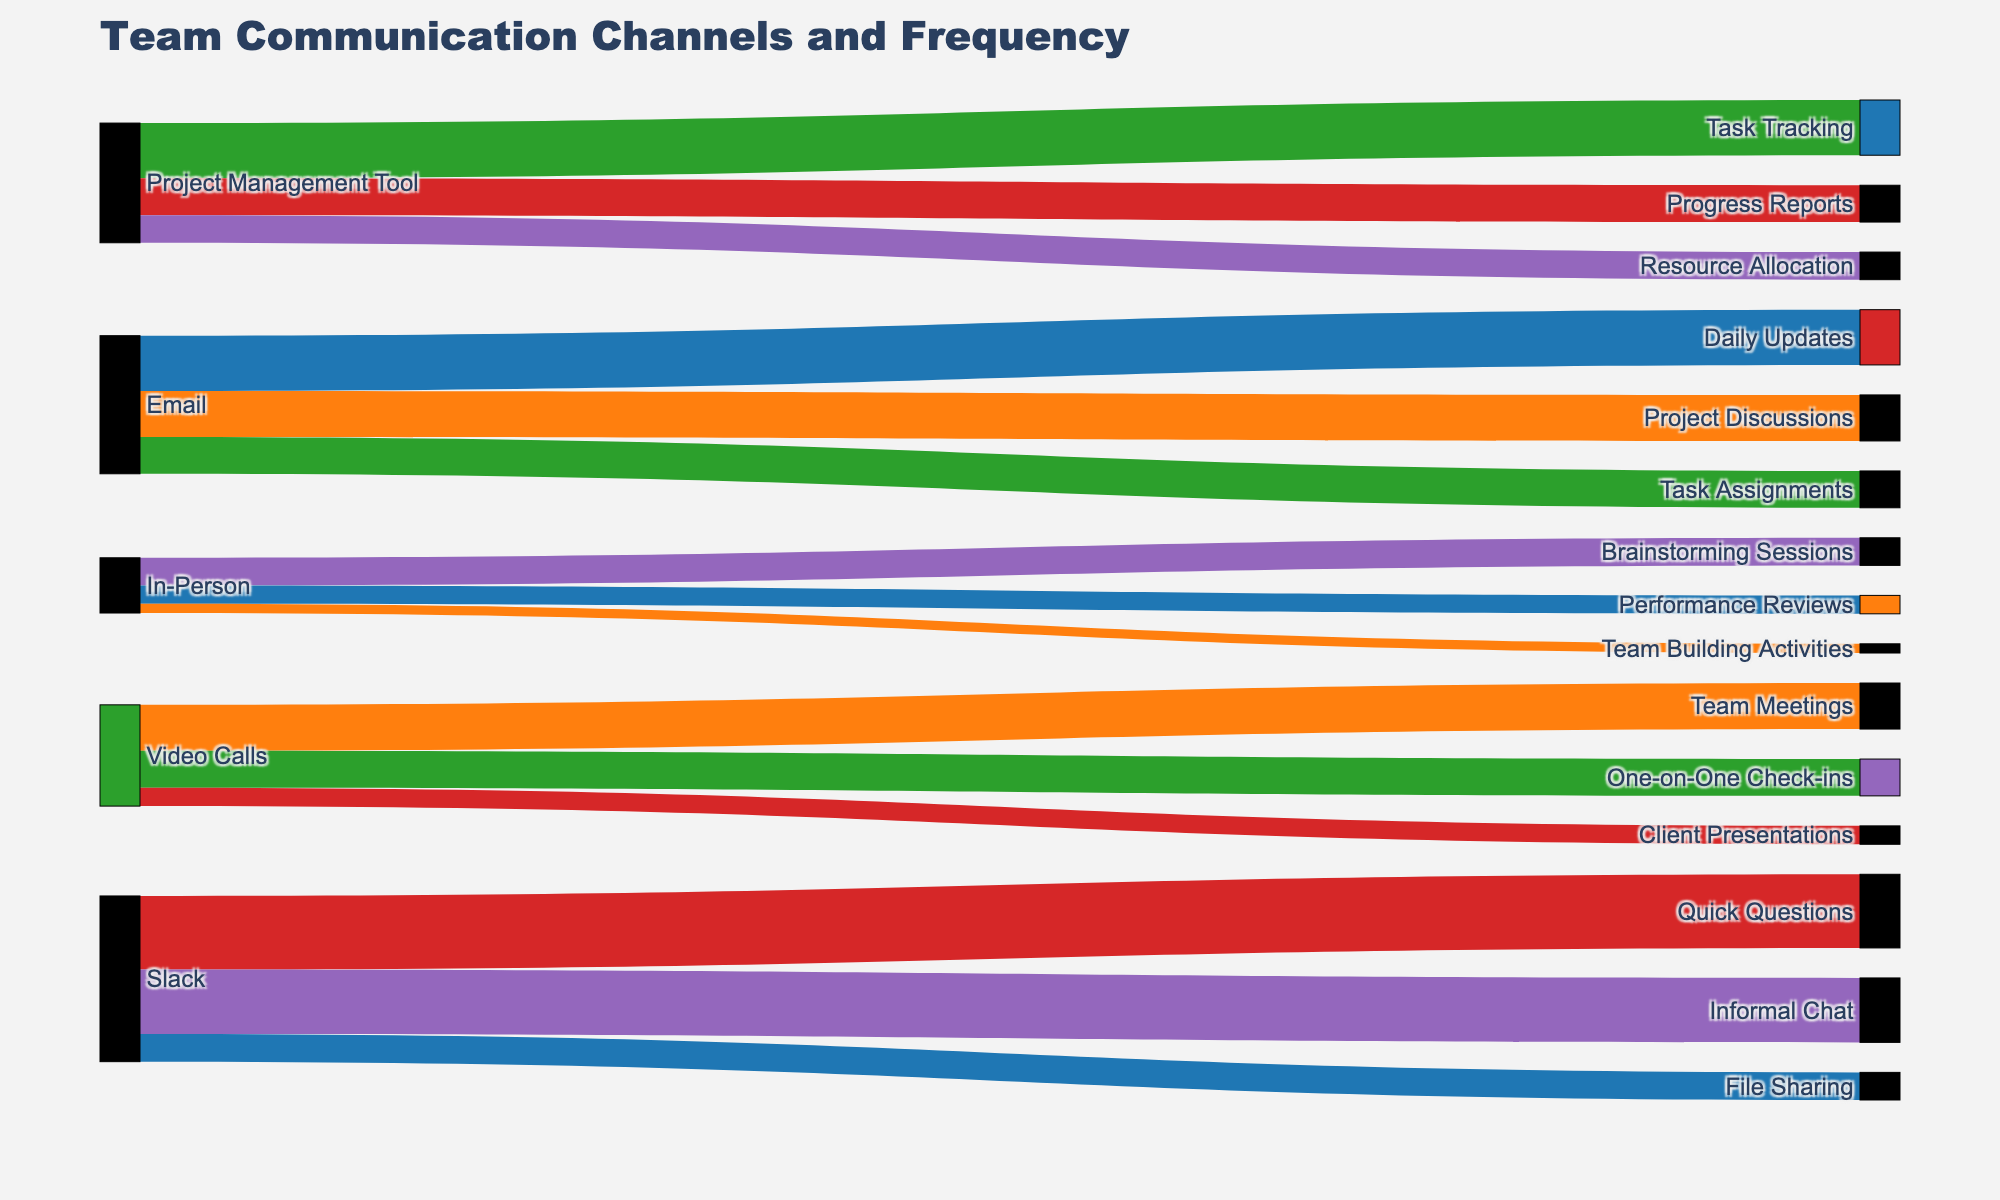What is the title of the diagram? The title is located at the top of the diagram. It is the largest text and visually separated from other elements.
Answer: Team Communication Channels and Frequency Which communication channel has the highest frequency for 'Quick Questions'? By observing the links in the Sankey diagram, the communication channel leading to 'Quick Questions' with the highest value is 'Slack'.
Answer: Slack How many different communication channels are shown in the diagram? By counting the unique 'Source' elements in the Sankey diagram, we can determine there are five communication channels: Email, Slack, Video Calls, In-Person, and Project Management Tool.
Answer: 5 What is the total frequency of in-person communication channels combined? To find the total frequency for in-person channels, sum up the values of 'Brainstorming Sessions', 'Performance Reviews', and 'Team Building Activities': 15 + 10 + 5.
Answer: 30 Compare the frequency of 'Project Management Tool' used for 'Task Tracking' and 'Resource Allocation'. Which one is higher? By checking the values in the Sankey diagram, 'Task Tracking' has a value of 30 and 'Resource Allocation' has a value of 15. Therefore, 'Task Tracking' is higher.
Answer: Task Tracking What is the least frequent communication means used for 'Client Presentations'? By looking at the values linked to 'Client Presentations', the only communication means linked is 'Video Calls' with a value of 10.
Answer: Video Calls Which communication channel is used the most for 'Team Meetings'? By examining the links, 'Video Calls' is used for 'Team Meetings' with a value of 25, which is the most in comparison to others.
Answer: Video Calls What percentage of Slack communication is used for 'File Sharing'? To find this, we divide the 'File Sharing' value by the total Slack communication values (40 + 35 + 15), then multiply by 100: (15 / (40 + 35 + 15)) * 100.
Answer: 15% How does the number of activities facilitated by 'Video Calls' compare to those facilitated by 'In-Person' communication? By counting the unique 'Target' elements linked to each 'Source', 'Video Calls' facilitates three activities while 'In-Person' also facilitates three activities.
Answer: Equal Which communication channel is used primarily for 'Progress Reports'? The diagram shows that 'Progress Reports' is linked to 'Project Management Tool' with a value of 20, making it the primary channel.
Answer: Project Management Tool 